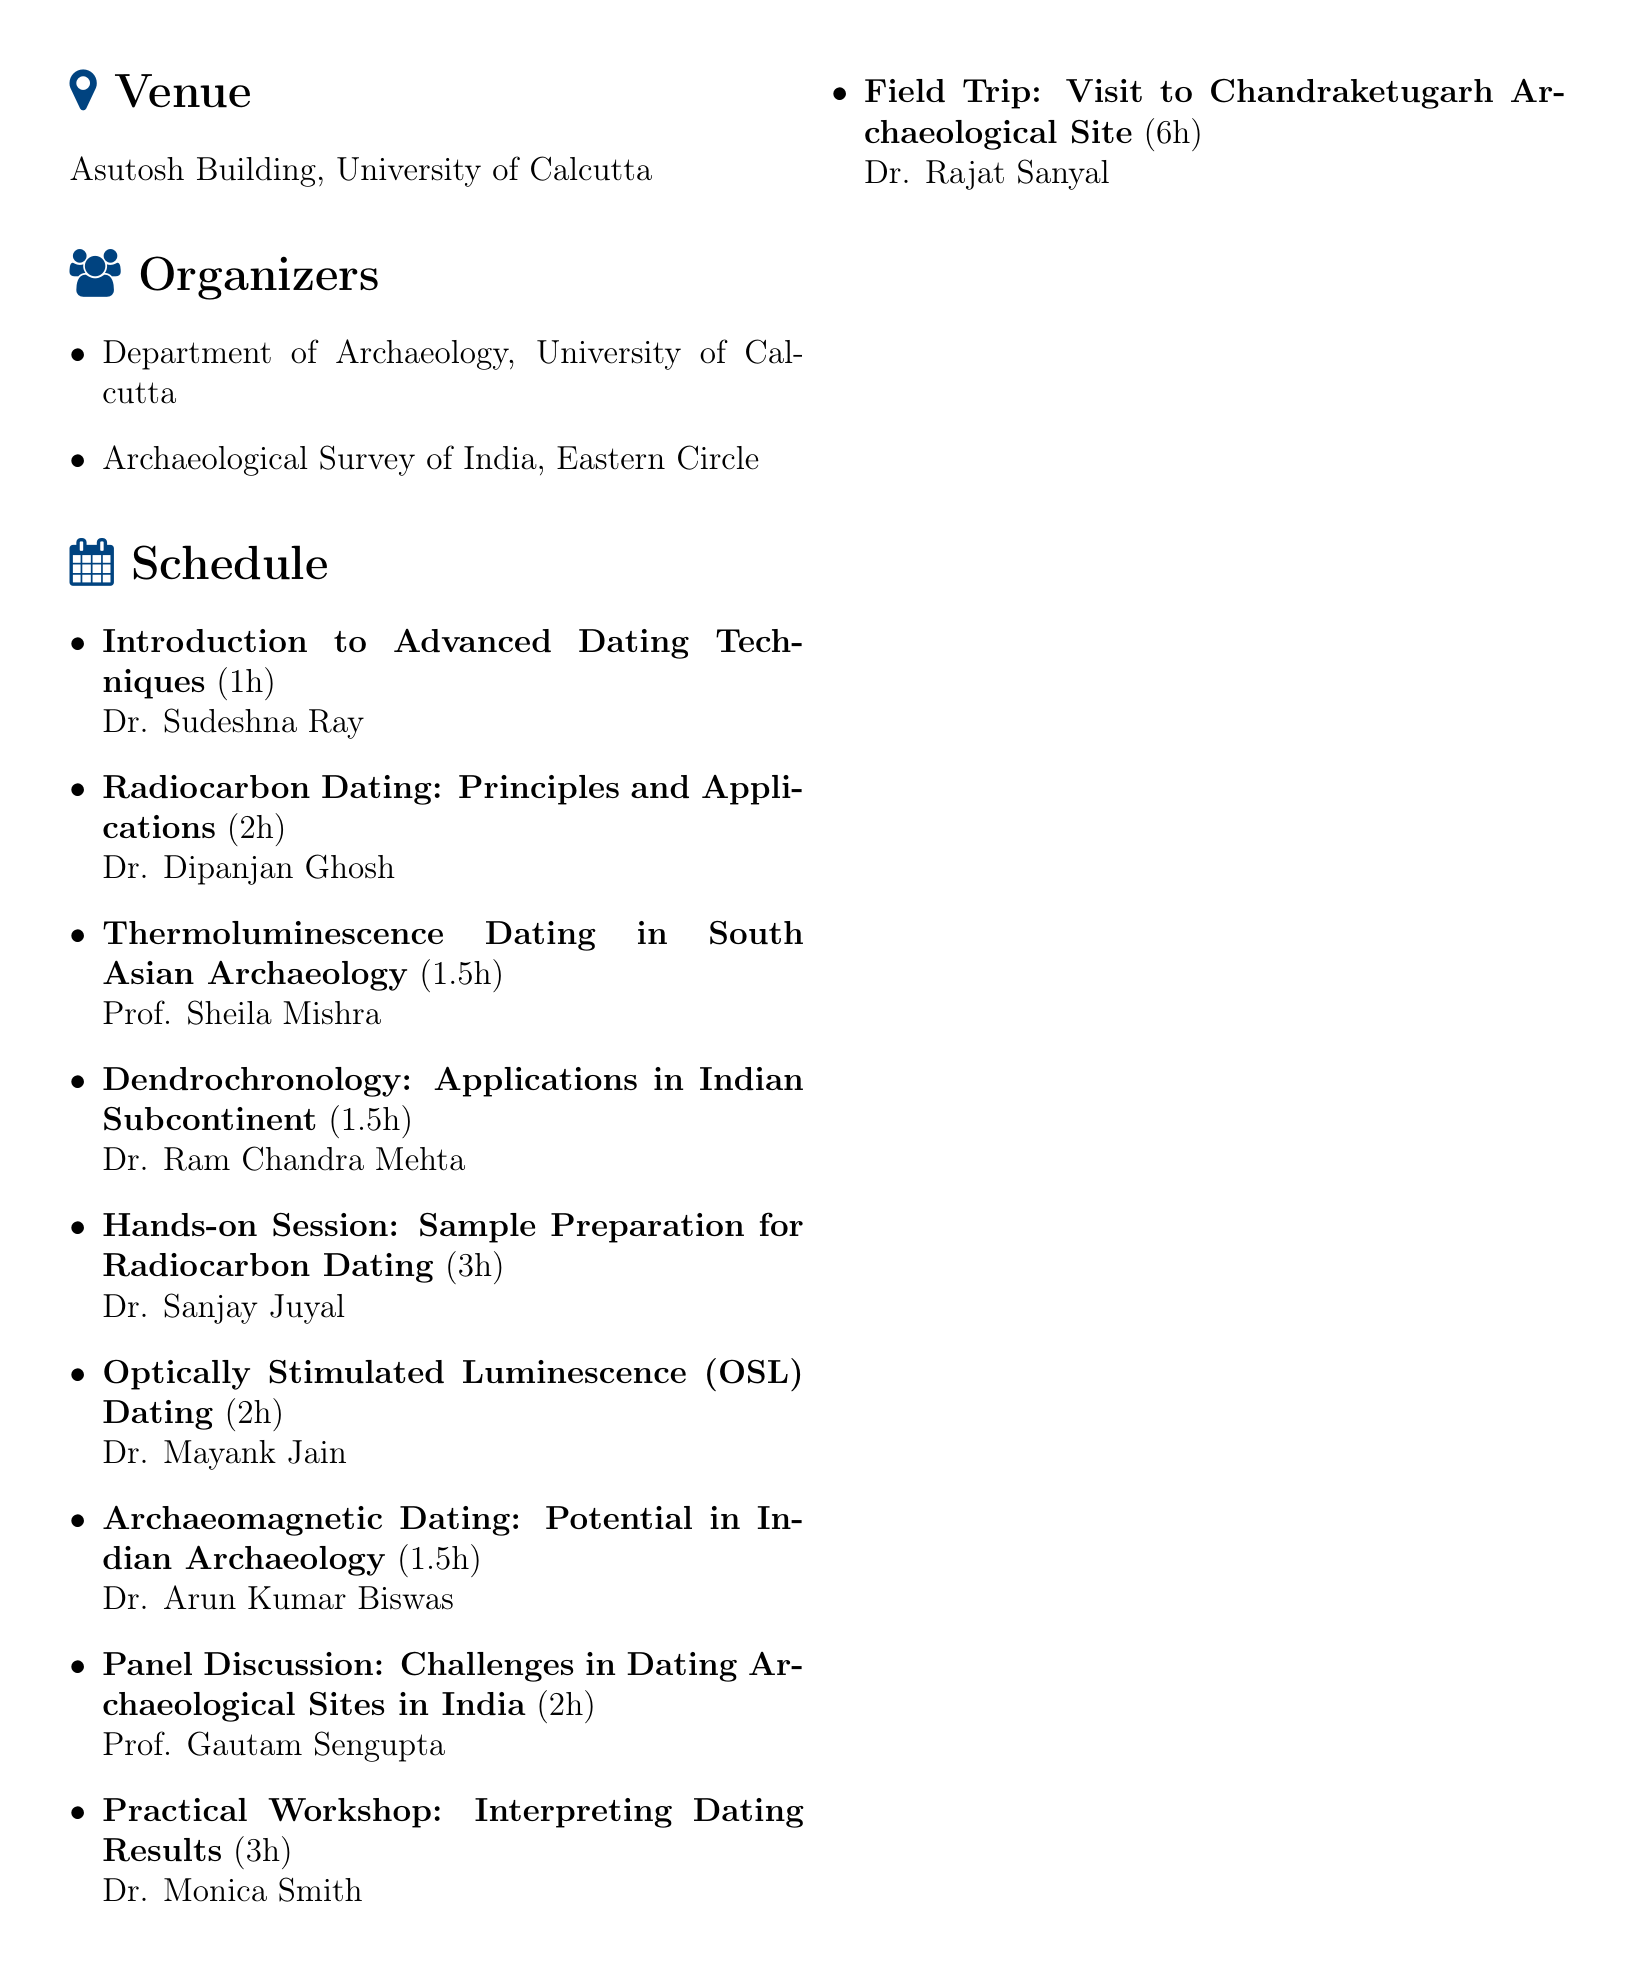What is the title of the workshop? The title of the workshop is specified in the document as part of the header section.
Answer: Advanced Dating Techniques in Archaeology: From Theory to Practice When is the workshop scheduled? The date of the workshop is clearly mentioned in the document.
Answer: September 15-17, 2023 Who is the facilitator for the hands-on session? The document specifies the facilitator's name for the hands-on session titled "Sample Preparation for Radiocarbon Dating."
Answer: Dr. Sanjay Juyal How long is the panel discussion scheduled for? The duration of the panel discussion is outlined in the schedule section of the document.
Answer: 2 hours What is the registration fee for students? The fee structure for registration is detailed in the document, specifically for students.
Answer: Rs. 2000 Which institution is organizing the workshop? The document lists the organizers, which includes a specific department and an organization.
Answer: Department of Archaeology, University of Calcutta What is one accommodation option mentioned in the document? The accommodation options are provided, and one option is explicitly stated.
Answer: University Guest House Who is the contact person for the workshop? The document provides a contact person along with their contact information.
Answer: Dr. Abhijit Dey What is the duration of the field trip? The document includes the duration of the field trip to the archaeological site in the schedule section.
Answer: 6 hours 